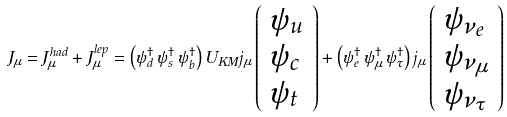Convert formula to latex. <formula><loc_0><loc_0><loc_500><loc_500>J _ { \mu } = J _ { \mu } ^ { h a d } + J _ { \mu } ^ { l e p } = \left ( \psi _ { d } ^ { \dagger } \, \psi _ { s } ^ { \dagger } \, \psi _ { b } ^ { \dagger } \right ) U _ { K M } j _ { \mu } \left ( \begin{array} { l } { { \psi _ { u } } } \\ { { \psi _ { c } } } \\ { { \psi _ { t } } } \end{array} \right ) + \left ( \psi _ { e } ^ { \dagger } \, \psi _ { \mu } ^ { \dagger } \, \psi _ { \tau } ^ { \dagger } \right ) j _ { \mu } \left ( \begin{array} { l } { { \psi _ { \nu _ { e } } } } \\ { { \psi _ { \nu _ { \mu } } } } \\ { { \psi _ { \nu _ { \tau } } } } \end{array} \right )</formula> 